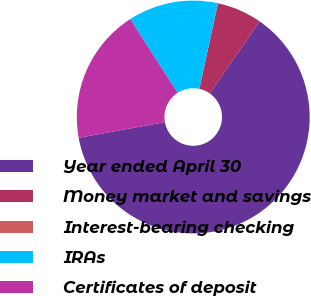Convert chart to OTSL. <chart><loc_0><loc_0><loc_500><loc_500><pie_chart><fcel>Year ended April 30<fcel>Money market and savings<fcel>Interest-bearing checking<fcel>IRAs<fcel>Certificates of deposit<nl><fcel>62.48%<fcel>6.26%<fcel>0.01%<fcel>12.5%<fcel>18.75%<nl></chart> 